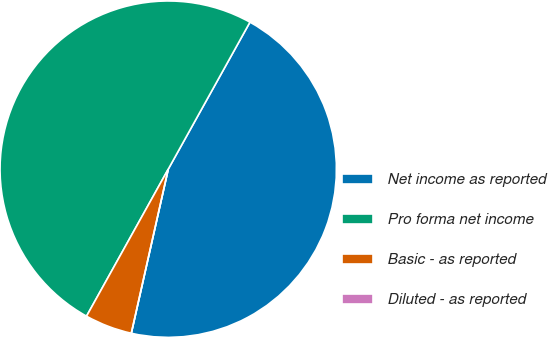Convert chart. <chart><loc_0><loc_0><loc_500><loc_500><pie_chart><fcel>Net income as reported<fcel>Pro forma net income<fcel>Basic - as reported<fcel>Diluted - as reported<nl><fcel>45.45%<fcel>50.0%<fcel>4.55%<fcel>0.0%<nl></chart> 